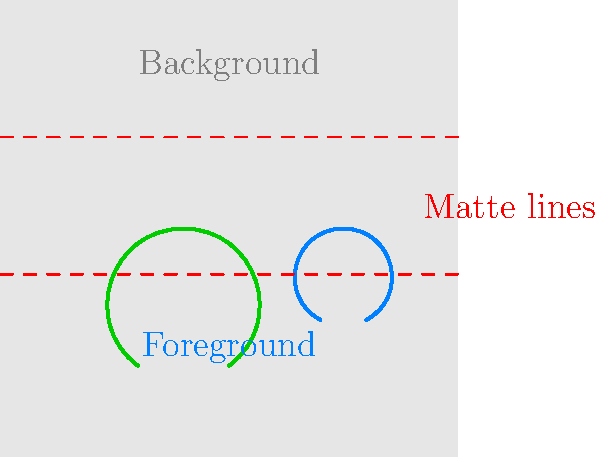In this simplified representation of a movie scene, which visual effects technique is being illustrated, and how does it contribute to creating complex composite shots? To identify the visual effects technique and understand its contribution to complex composite shots, let's analyze the image step-by-step:

1. The image shows a scene divided into three distinct areas:
   - A background (top section)
   - Two foreground elements (tree and actor in the middle)
   - Red dashed lines separating these areas

2. The red dashed lines are labeled as "Matte lines," which is a key indicator of the technique being used.

3. This representation illustrates the "Matte Painting" technique, which has evolved from traditional painted backdrops to digital compositing.

4. In Matte Painting:
   - The background is typically a highly detailed, static image (either painted or digitally created).
   - Foreground elements (like the tree and actor) are filmed separately, often against a blue or green screen.
   - Matte lines define the areas where foreground and background elements will be combined.

5. This technique contributes to creating complex composite shots by:
   - Allowing filmmakers to create elaborate, fantastical, or historical settings that would be impossible or extremely expensive to build or film in reality.
   - Enabling the combination of live-action footage with painted or CGI backgrounds seamlessly.
   - Providing control over each element of the scene independently, allowing for precise adjustments and enhancements.
   - Facilitating the creation of shots that would be dangerous or impractical to film in real locations.

6. In modern filmmaking, digital matte painting has largely replaced traditional techniques, but the principle remains the same: combining separately created elements to form a cohesive, believable scene.

This technique is a cornerstone of visual effects in filmmaking, allowing directors of photography to expand the visual storytelling possibilities beyond the constraints of physical sets and locations.
Answer: Matte Painting 